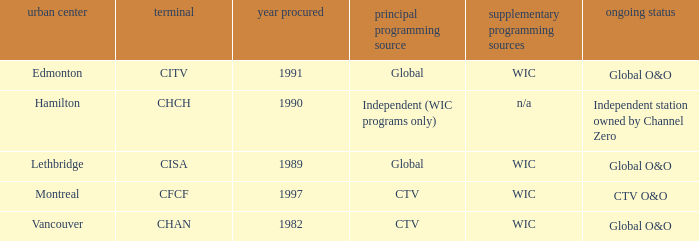How any were gained as the chan 1.0. 